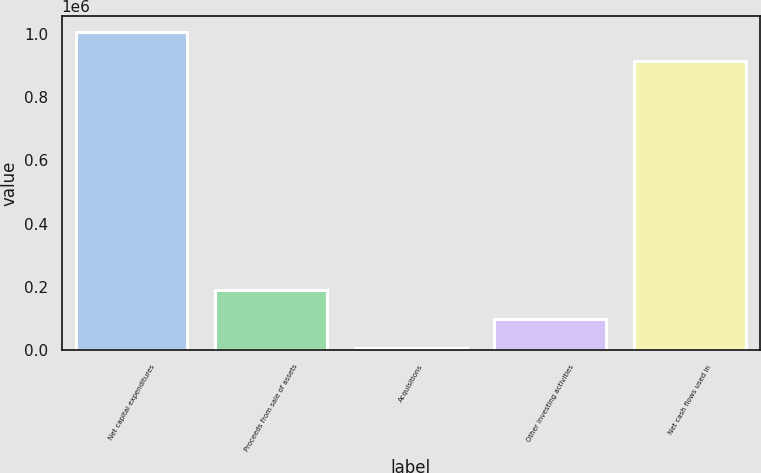<chart> <loc_0><loc_0><loc_500><loc_500><bar_chart><fcel>Net capital expenditures<fcel>Proceeds from sale of assets<fcel>Acquisitions<fcel>Other investing activities<fcel>Net cash flows used in<nl><fcel>1.00416e+06<fcel>190748<fcel>7220<fcel>98983.8<fcel>912397<nl></chart> 